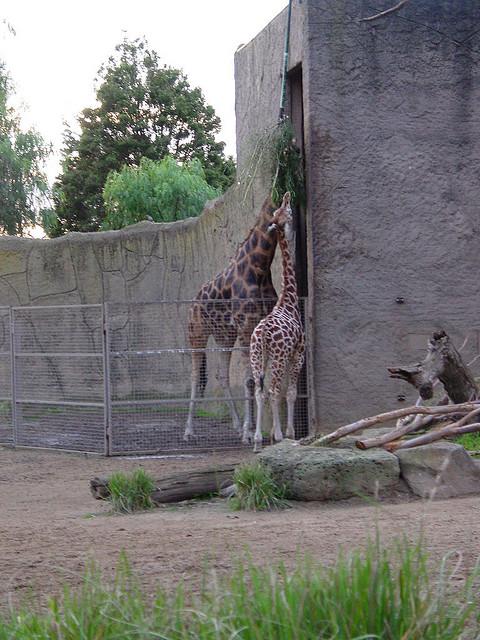What type of animals are they?
Write a very short answer. Giraffes. Are the animals eating?
Write a very short answer. Yes. What are the giraffes trying to reach?
Be succinct. Food. 